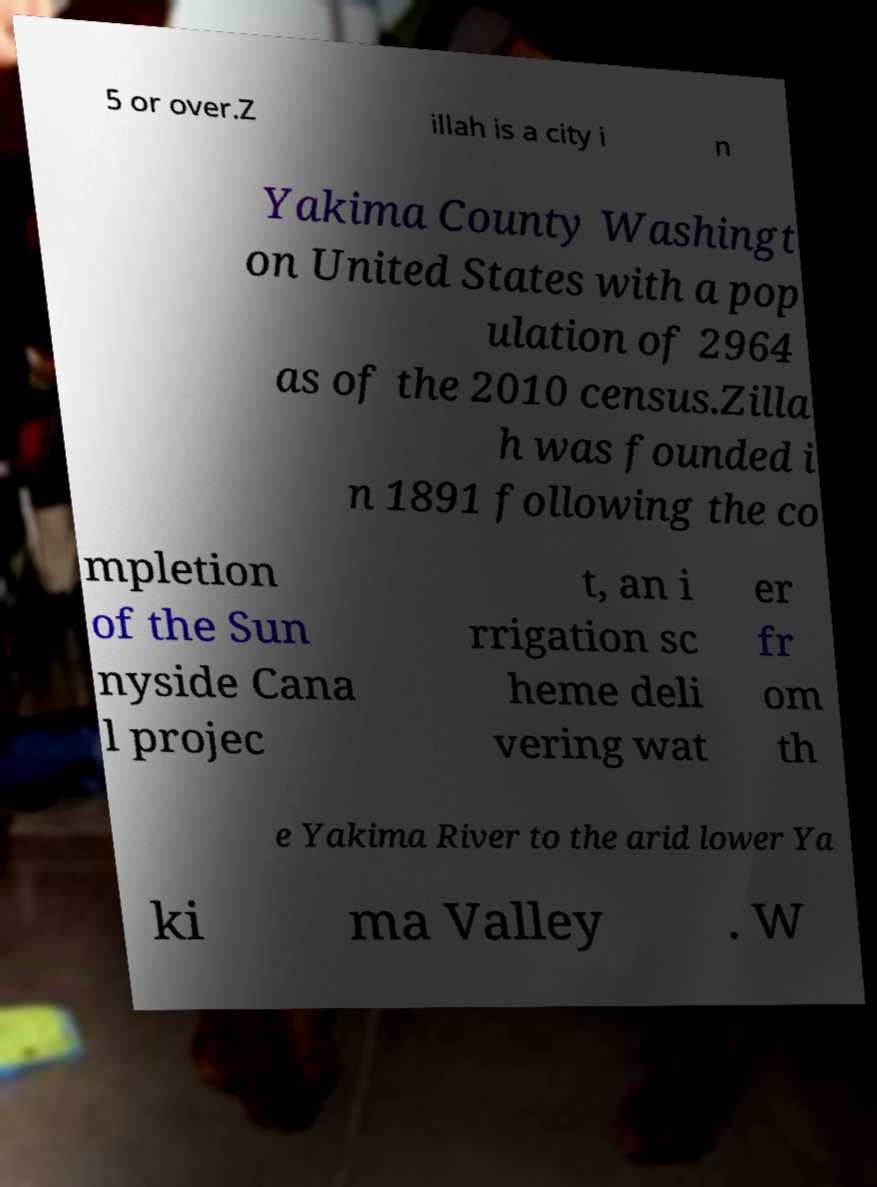There's text embedded in this image that I need extracted. Can you transcribe it verbatim? 5 or over.Z illah is a city i n Yakima County Washingt on United States with a pop ulation of 2964 as of the 2010 census.Zilla h was founded i n 1891 following the co mpletion of the Sun nyside Cana l projec t, an i rrigation sc heme deli vering wat er fr om th e Yakima River to the arid lower Ya ki ma Valley . W 